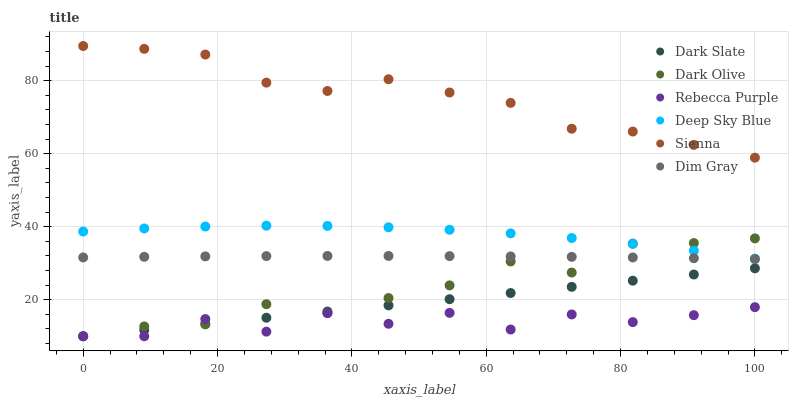Does Rebecca Purple have the minimum area under the curve?
Answer yes or no. Yes. Does Sienna have the maximum area under the curve?
Answer yes or no. Yes. Does Dark Olive have the minimum area under the curve?
Answer yes or no. No. Does Dark Olive have the maximum area under the curve?
Answer yes or no. No. Is Dark Slate the smoothest?
Answer yes or no. Yes. Is Rebecca Purple the roughest?
Answer yes or no. Yes. Is Dark Olive the smoothest?
Answer yes or no. No. Is Dark Olive the roughest?
Answer yes or no. No. Does Dark Olive have the lowest value?
Answer yes or no. Yes. Does Sienna have the lowest value?
Answer yes or no. No. Does Sienna have the highest value?
Answer yes or no. Yes. Does Dark Olive have the highest value?
Answer yes or no. No. Is Deep Sky Blue less than Sienna?
Answer yes or no. Yes. Is Deep Sky Blue greater than Rebecca Purple?
Answer yes or no. Yes. Does Dark Slate intersect Rebecca Purple?
Answer yes or no. Yes. Is Dark Slate less than Rebecca Purple?
Answer yes or no. No. Is Dark Slate greater than Rebecca Purple?
Answer yes or no. No. Does Deep Sky Blue intersect Sienna?
Answer yes or no. No. 